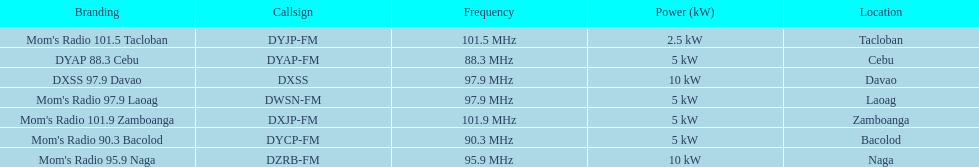What is the number of these stations broadcasting at a frequency of greater than 100 mhz? 2. Help me parse the entirety of this table. {'header': ['Branding', 'Callsign', 'Frequency', 'Power (kW)', 'Location'], 'rows': [["Mom's Radio 101.5 Tacloban", 'DYJP-FM', '101.5\xa0MHz', '2.5\xa0kW', 'Tacloban'], ['DYAP 88.3 Cebu', 'DYAP-FM', '88.3\xa0MHz', '5\xa0kW', 'Cebu'], ['DXSS 97.9 Davao', 'DXSS', '97.9\xa0MHz', '10\xa0kW', 'Davao'], ["Mom's Radio 97.9 Laoag", 'DWSN-FM', '97.9\xa0MHz', '5\xa0kW', 'Laoag'], ["Mom's Radio 101.9 Zamboanga", 'DXJP-FM', '101.9\xa0MHz', '5\xa0kW', 'Zamboanga'], ["Mom's Radio 90.3 Bacolod", 'DYCP-FM', '90.3\xa0MHz', '5\xa0kW', 'Bacolod'], ["Mom's Radio 95.9 Naga", 'DZRB-FM', '95.9\xa0MHz', '10\xa0kW', 'Naga']]} 